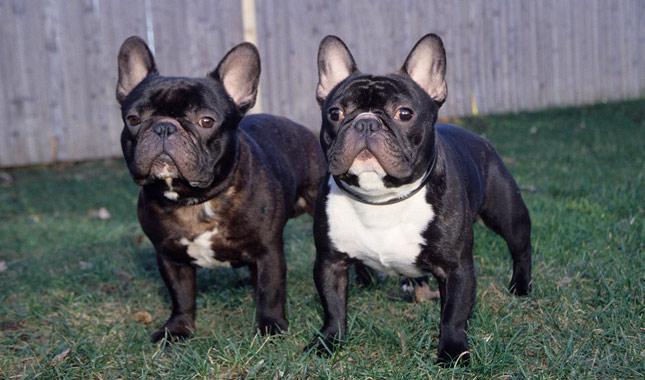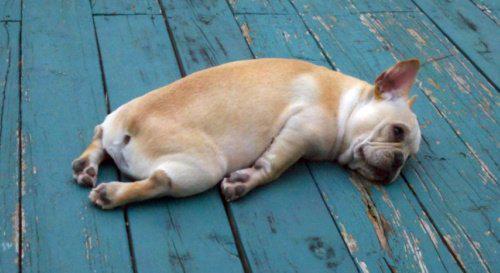The first image is the image on the left, the second image is the image on the right. Analyze the images presented: Is the assertion "There are three french bulldogs" valid? Answer yes or no. Yes. The first image is the image on the left, the second image is the image on the right. For the images displayed, is the sentence "A total of two blackish dogs are shown." factually correct? Answer yes or no. Yes. 